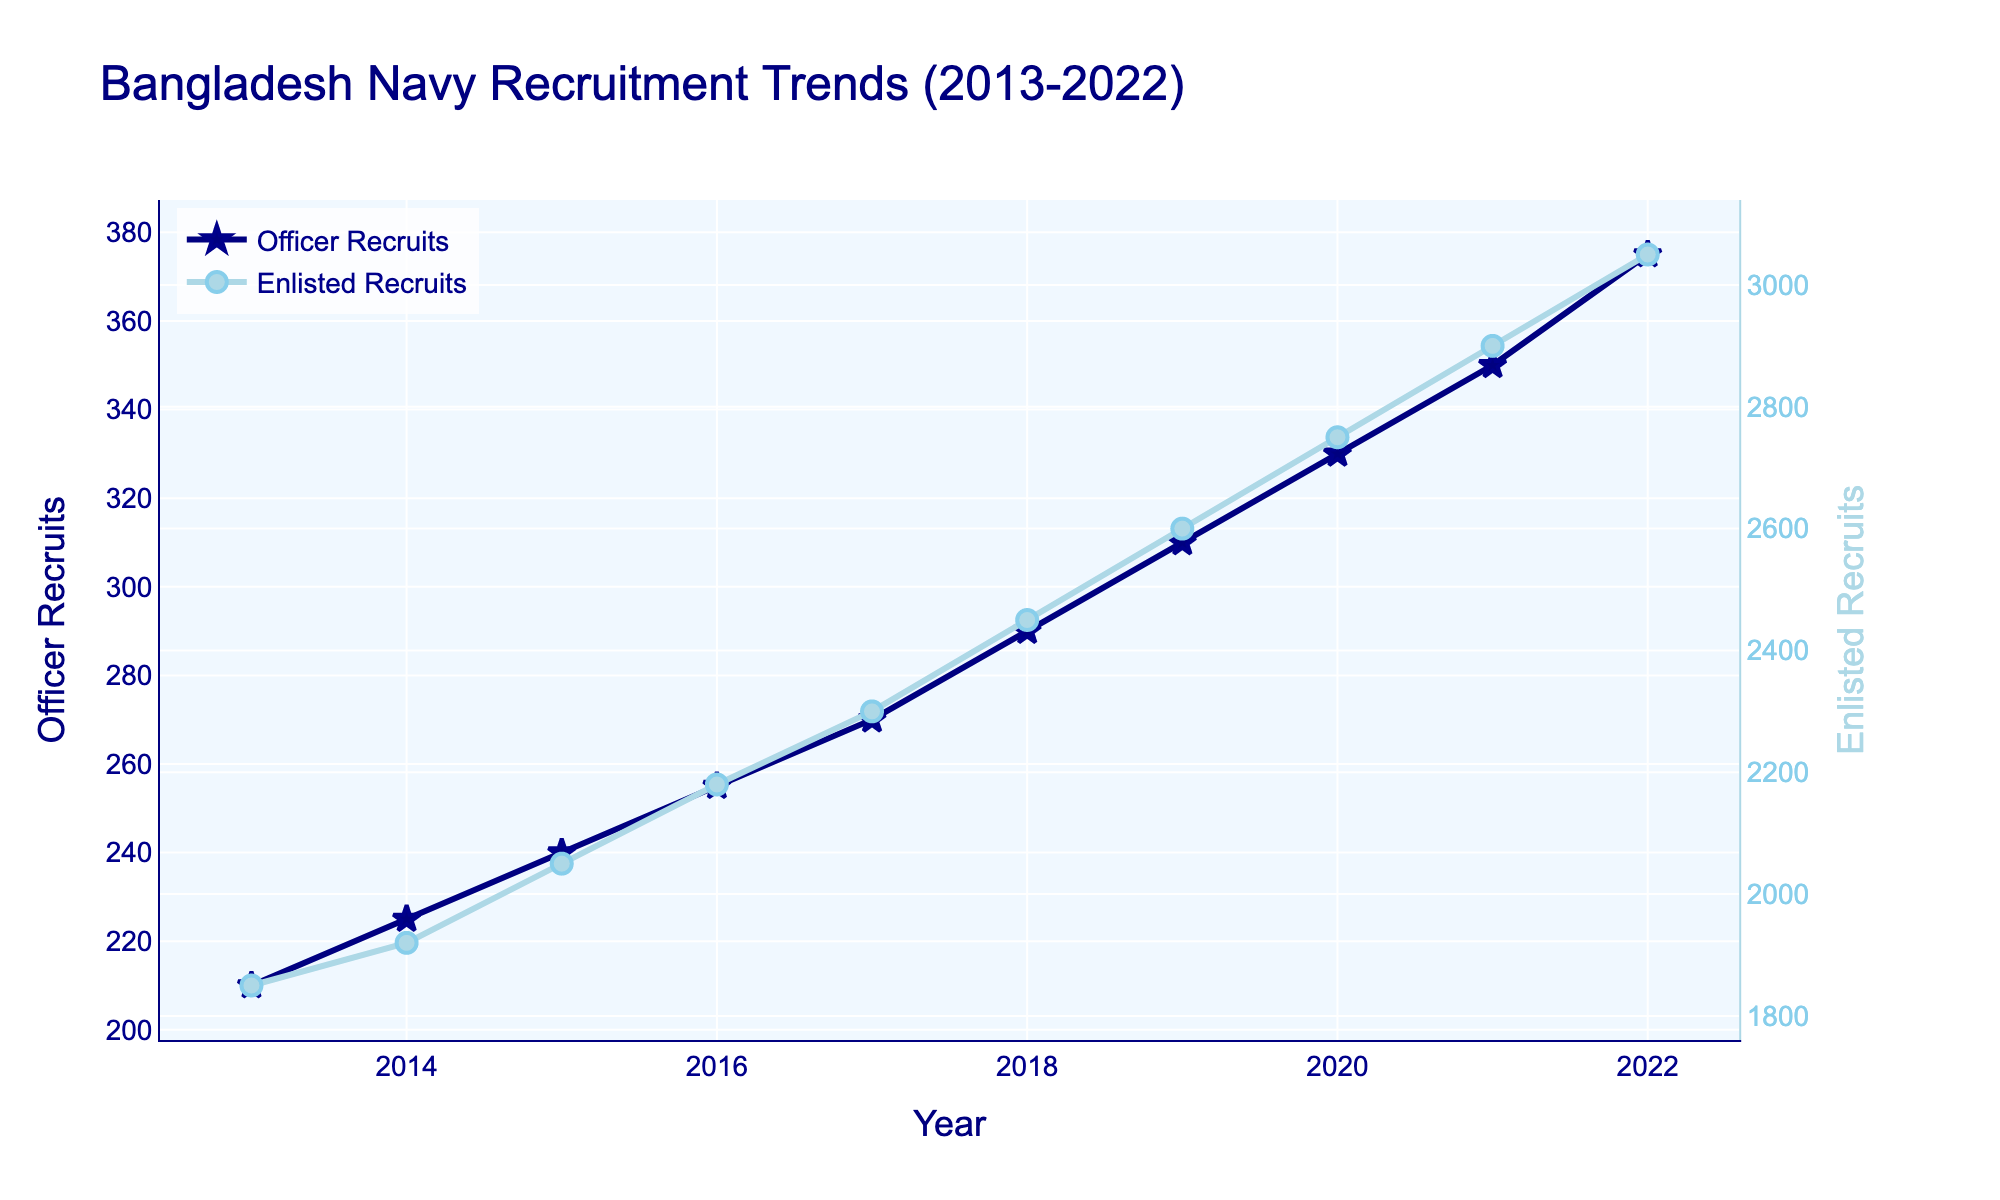What was the number of Officer Recruits in 2017? Locate the data point for the year 2017 on the line for Officer Recruits, which is marked by a star symbol and colored in navy. The corresponding y-value is 270.
Answer: 270 By how much did the number of Enlisted Recruits increase from 2013 to 2022? Identify the number of Enlisted Recruits in 2013 and 2022. The Enlisted Recruits were 1850 in 2013 and 3050 in 2022. Subtract the 2013 value from the 2022 value: 3050 - 1850 = 1200.
Answer: 1200 In which year did the number of Officer Recruits surpass 300? Find the point where the Officer Recruits line first crosses the y-axis value of 300. This happens in the year 2019.
Answer: 2019 Did both Officer and Enlisted Recruits steadily increase every year? Examine the trends for both Officer and Enlisted Recruits from 2013 to 2022. Both lines show a consistent upward trend with no decreases, indicating a steady increase.
Answer: Yes What is the average annual increase in the number of Enlisted Recruits over the decade? Calculate the total increase in Enlisted Recruits from 2013 (1850) to 2022 (3050), which is 3050 - 1850 = 1200. Then, divide this increase by the number of years (2022 - 2013 = 9 years): 1200 / 9 = 133.33.
Answer: 133.33 How does the trend in Officer Recruits compare visually to the trend in Enlisted Recruits? Observe the slopes of the lines representing Officer and Enlisted Recruits. Both lines are increasing, but the Enlisted Recruits line is higher and shows a larger absolute increase. The Officer Recruits line has a more gradual slope.
Answer: Enlisted Recruits have a steeper increase In which year did the Enlisted Recruits reach 2750? Identify the year when the Enlisted Recruits line, marked by circle symbols and colored light blue, crosses the y-axis value of 2750. This occurs in the year 2020.
Answer: 2020 What's the difference in the number of Officer and Enlisted Recruits in 2022? Identify the number of Officer Recruits (375) and Enlisted Recruits (3050) in 2022. Subtract the number of Officer Recruits from the number of Enlisted Recruits: 3050 - 375 = 2675.
Answer: 2675 